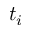Convert formula to latex. <formula><loc_0><loc_0><loc_500><loc_500>t _ { i }</formula> 